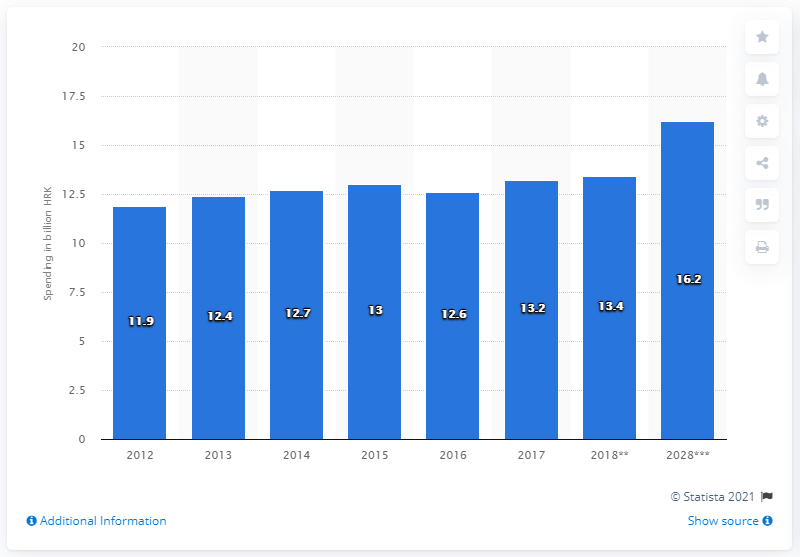Give some essential details in this illustration. In 2017, a significant amount of Croatian kunas was spent on tourism. 